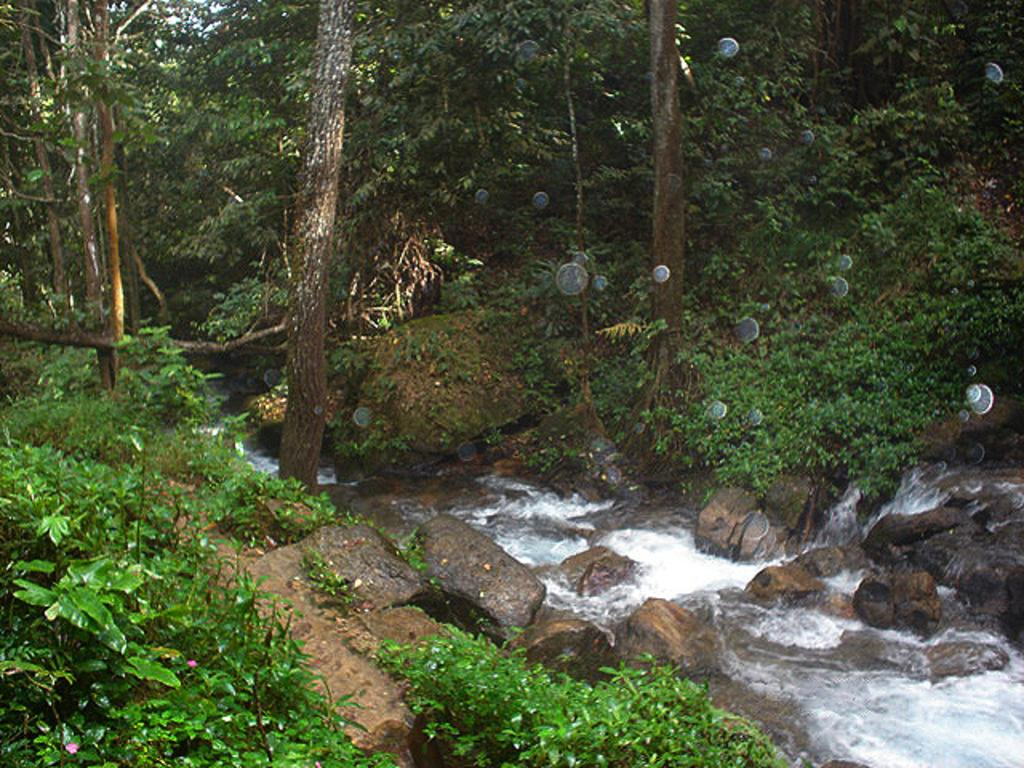What type of living organisms can be seen in the image? Plants and trees are visible in the image. What type of natural elements can be seen in the image? Rocks and water are visible in the image. What else is present in the image besides plants, rocks, and water? There are objects in the image. What can be seen in the background of the image? Trees are visible in the background of the image. How many children are playing with the quilt in the image? There are no children or quilts present in the image. What type of furniture is the secretary using in the image? There is no furniture or secretary present in the image. 